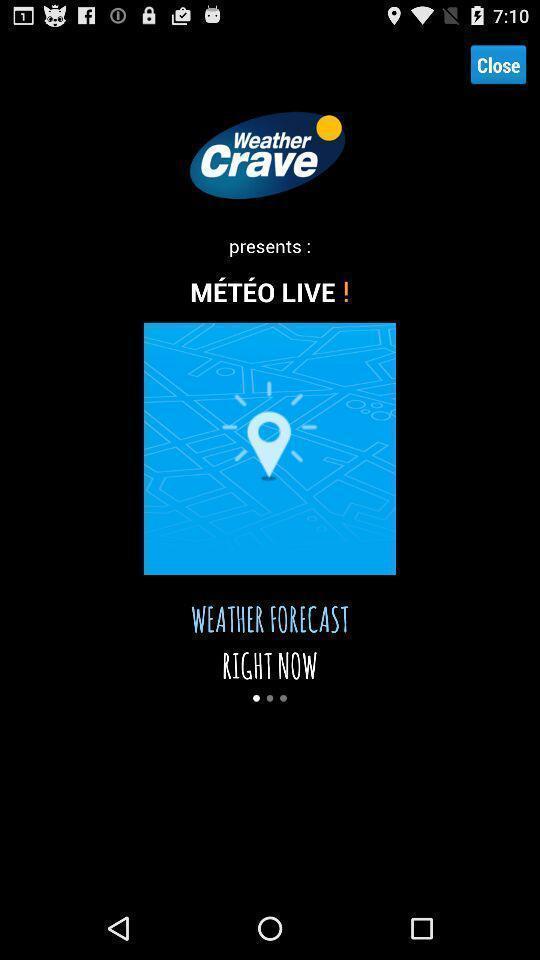What is the overall content of this screenshot? Welcome page. 